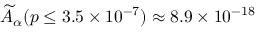<formula> <loc_0><loc_0><loc_500><loc_500>\widetilde { A } _ { \alpha } ( p \leq 3 . 5 \times 1 0 ^ { - 7 } ) \approx 8 . 9 \times 1 0 ^ { - 1 8 }</formula> 